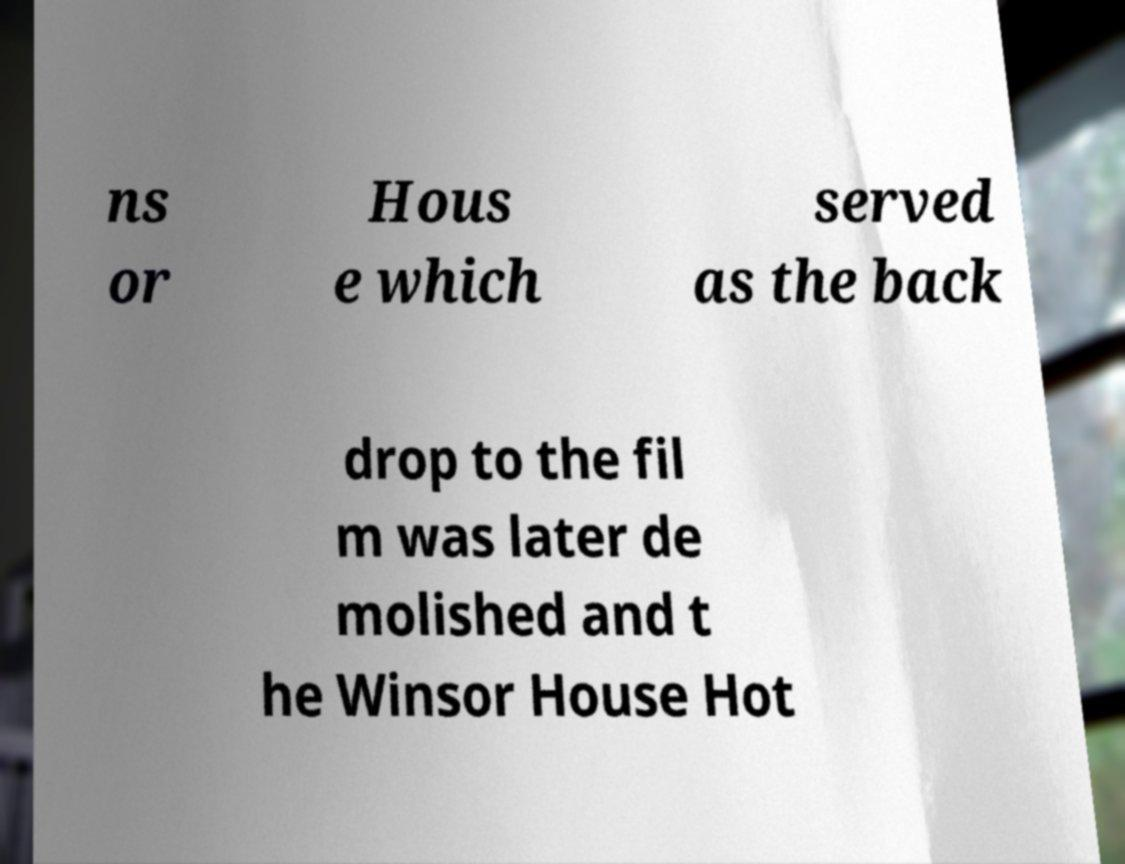I need the written content from this picture converted into text. Can you do that? ns or Hous e which served as the back drop to the fil m was later de molished and t he Winsor House Hot 